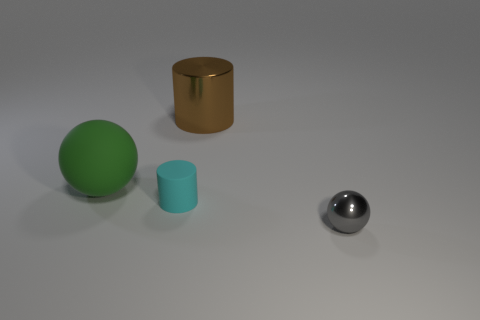What textures do the objects appear to have? The objects have varying textures. The large green sphere and the smaller blue cylinder have a matte finish, while the gold cylinder has a slightly reflective surface. The small silver sphere has a highly reflective, almost mirror-like surface that stands out from the rest. 